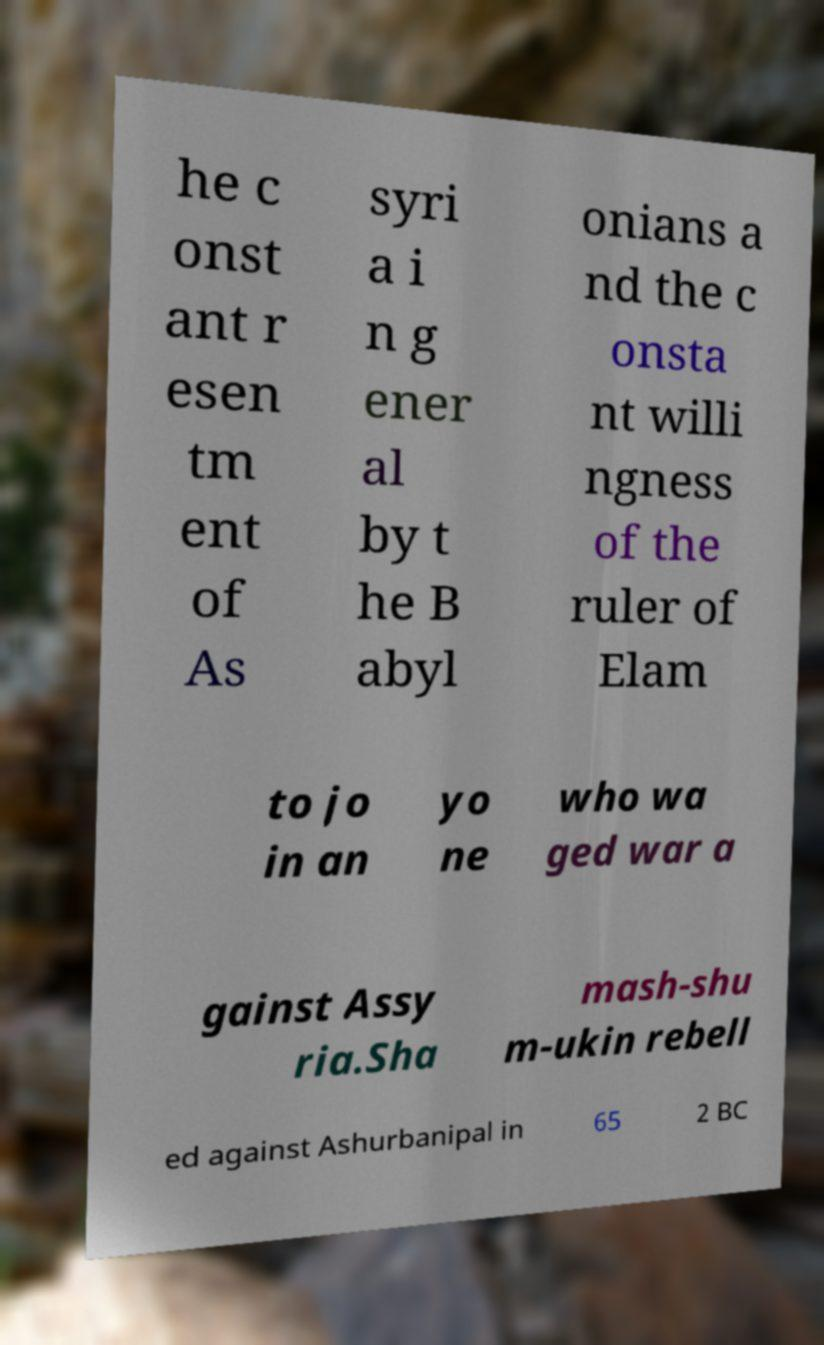Could you assist in decoding the text presented in this image and type it out clearly? he c onst ant r esen tm ent of As syri a i n g ener al by t he B abyl onians a nd the c onsta nt willi ngness of the ruler of Elam to jo in an yo ne who wa ged war a gainst Assy ria.Sha mash-shu m-ukin rebell ed against Ashurbanipal in 65 2 BC 